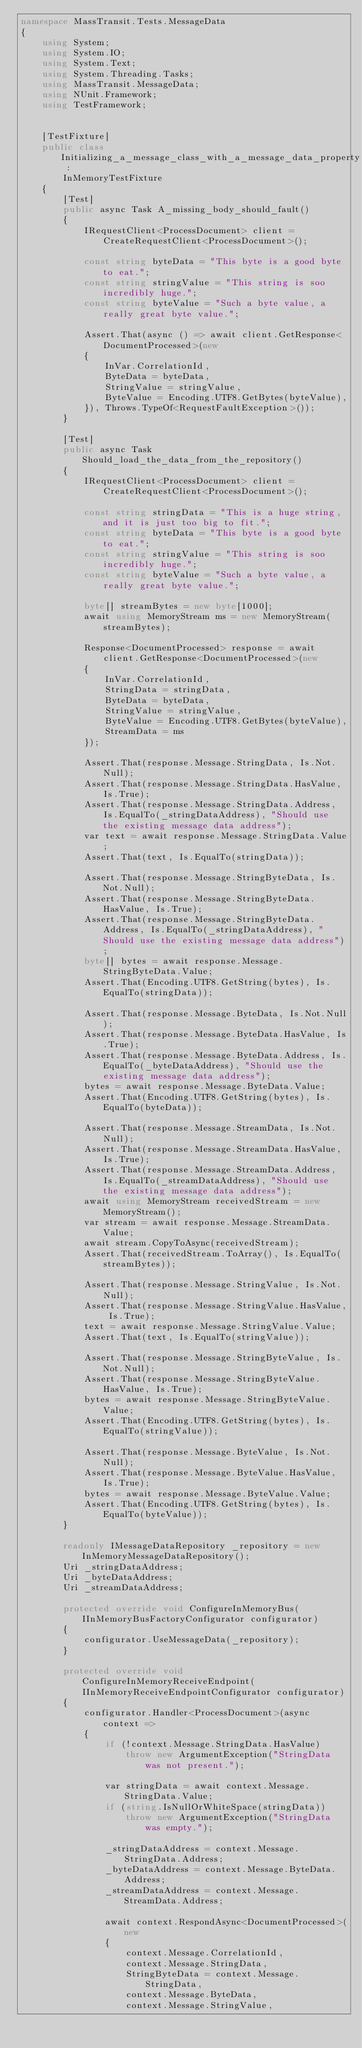Convert code to text. <code><loc_0><loc_0><loc_500><loc_500><_C#_>namespace MassTransit.Tests.MessageData
{
    using System;
    using System.IO;
    using System.Text;
    using System.Threading.Tasks;
    using MassTransit.MessageData;
    using NUnit.Framework;
    using TestFramework;


    [TestFixture]
    public class Initializing_a_message_class_with_a_message_data_property :
        InMemoryTestFixture
    {
        [Test]
        public async Task A_missing_body_should_fault()
        {
            IRequestClient<ProcessDocument> client = CreateRequestClient<ProcessDocument>();

            const string byteData = "This byte is a good byte to eat.";
            const string stringValue = "This string is soo incredibly huge.";
            const string byteValue = "Such a byte value, a really great byte value.";

            Assert.That(async () => await client.GetResponse<DocumentProcessed>(new
            {
                InVar.CorrelationId,
                ByteData = byteData,
                StringValue = stringValue,
                ByteValue = Encoding.UTF8.GetBytes(byteValue),
            }), Throws.TypeOf<RequestFaultException>());
        }

        [Test]
        public async Task Should_load_the_data_from_the_repository()
        {
            IRequestClient<ProcessDocument> client = CreateRequestClient<ProcessDocument>();

            const string stringData = "This is a huge string, and it is just too big to fit.";
            const string byteData = "This byte is a good byte to eat.";
            const string stringValue = "This string is soo incredibly huge.";
            const string byteValue = "Such a byte value, a really great byte value.";

            byte[] streamBytes = new byte[1000];
            await using MemoryStream ms = new MemoryStream(streamBytes);

            Response<DocumentProcessed> response = await client.GetResponse<DocumentProcessed>(new
            {
                InVar.CorrelationId,
                StringData = stringData,
                ByteData = byteData,
                StringValue = stringValue,
                ByteValue = Encoding.UTF8.GetBytes(byteValue),
                StreamData = ms
            });

            Assert.That(response.Message.StringData, Is.Not.Null);
            Assert.That(response.Message.StringData.HasValue, Is.True);
            Assert.That(response.Message.StringData.Address, Is.EqualTo(_stringDataAddress), "Should use the existing message data address");
            var text = await response.Message.StringData.Value;
            Assert.That(text, Is.EqualTo(stringData));

            Assert.That(response.Message.StringByteData, Is.Not.Null);
            Assert.That(response.Message.StringByteData.HasValue, Is.True);
            Assert.That(response.Message.StringByteData.Address, Is.EqualTo(_stringDataAddress), "Should use the existing message data address");
            byte[] bytes = await response.Message.StringByteData.Value;
            Assert.That(Encoding.UTF8.GetString(bytes), Is.EqualTo(stringData));

            Assert.That(response.Message.ByteData, Is.Not.Null);
            Assert.That(response.Message.ByteData.HasValue, Is.True);
            Assert.That(response.Message.ByteData.Address, Is.EqualTo(_byteDataAddress), "Should use the existing message data address");
            bytes = await response.Message.ByteData.Value;
            Assert.That(Encoding.UTF8.GetString(bytes), Is.EqualTo(byteData));

            Assert.That(response.Message.StreamData, Is.Not.Null);
            Assert.That(response.Message.StreamData.HasValue, Is.True);
            Assert.That(response.Message.StreamData.Address, Is.EqualTo(_streamDataAddress), "Should use the existing message data address");
            await using MemoryStream receivedStream = new MemoryStream();
            var stream = await response.Message.StreamData.Value;
            await stream.CopyToAsync(receivedStream);
            Assert.That(receivedStream.ToArray(), Is.EqualTo(streamBytes));

            Assert.That(response.Message.StringValue, Is.Not.Null);
            Assert.That(response.Message.StringValue.HasValue, Is.True);
            text = await response.Message.StringValue.Value;
            Assert.That(text, Is.EqualTo(stringValue));

            Assert.That(response.Message.StringByteValue, Is.Not.Null);
            Assert.That(response.Message.StringByteValue.HasValue, Is.True);
            bytes = await response.Message.StringByteValue.Value;
            Assert.That(Encoding.UTF8.GetString(bytes), Is.EqualTo(stringValue));

            Assert.That(response.Message.ByteValue, Is.Not.Null);
            Assert.That(response.Message.ByteValue.HasValue, Is.True);
            bytes = await response.Message.ByteValue.Value;
            Assert.That(Encoding.UTF8.GetString(bytes), Is.EqualTo(byteValue));
        }

        readonly IMessageDataRepository _repository = new InMemoryMessageDataRepository();
        Uri _stringDataAddress;
        Uri _byteDataAddress;
        Uri _streamDataAddress;

        protected override void ConfigureInMemoryBus(IInMemoryBusFactoryConfigurator configurator)
        {
            configurator.UseMessageData(_repository);
        }

        protected override void ConfigureInMemoryReceiveEndpoint(IInMemoryReceiveEndpointConfigurator configurator)
        {
            configurator.Handler<ProcessDocument>(async context =>
            {
                if (!context.Message.StringData.HasValue)
                    throw new ArgumentException("StringData was not present.");

                var stringData = await context.Message.StringData.Value;
                if (string.IsNullOrWhiteSpace(stringData))
                    throw new ArgumentException("StringData was empty.");

                _stringDataAddress = context.Message.StringData.Address;
                _byteDataAddress = context.Message.ByteData.Address;
                _streamDataAddress = context.Message.StreamData.Address;

                await context.RespondAsync<DocumentProcessed>(new
                {
                    context.Message.CorrelationId,
                    context.Message.StringData,
                    StringByteData = context.Message.StringData,
                    context.Message.ByteData,
                    context.Message.StringValue,</code> 